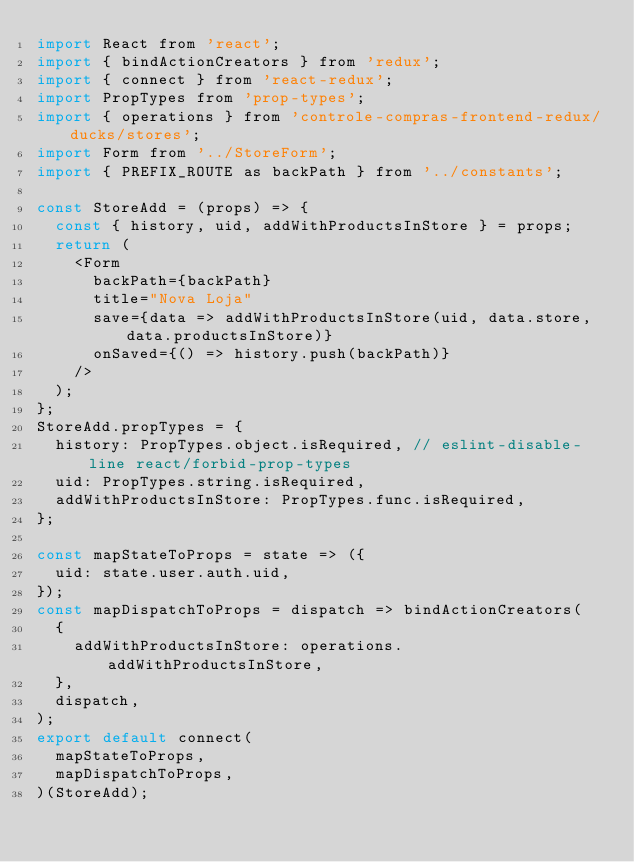Convert code to text. <code><loc_0><loc_0><loc_500><loc_500><_JavaScript_>import React from 'react';
import { bindActionCreators } from 'redux';
import { connect } from 'react-redux';
import PropTypes from 'prop-types';
import { operations } from 'controle-compras-frontend-redux/ducks/stores';
import Form from '../StoreForm';
import { PREFIX_ROUTE as backPath } from '../constants';

const StoreAdd = (props) => {
  const { history, uid, addWithProductsInStore } = props;
  return (
    <Form
      backPath={backPath}
      title="Nova Loja"
      save={data => addWithProductsInStore(uid, data.store, data.productsInStore)}
      onSaved={() => history.push(backPath)}
    />
  );
};
StoreAdd.propTypes = {
  history: PropTypes.object.isRequired, // eslint-disable-line react/forbid-prop-types
  uid: PropTypes.string.isRequired,
  addWithProductsInStore: PropTypes.func.isRequired,
};

const mapStateToProps = state => ({
  uid: state.user.auth.uid,
});
const mapDispatchToProps = dispatch => bindActionCreators(
  {
    addWithProductsInStore: operations.addWithProductsInStore,
  },
  dispatch,
);
export default connect(
  mapStateToProps,
  mapDispatchToProps,
)(StoreAdd);
</code> 